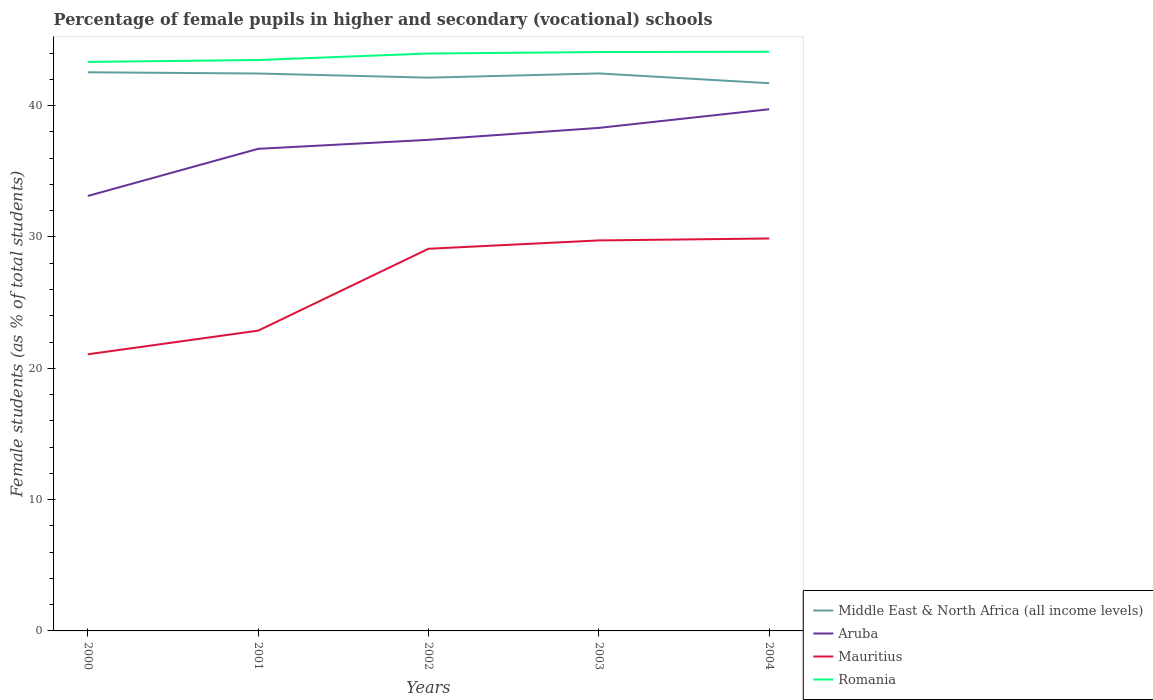Does the line corresponding to Aruba intersect with the line corresponding to Middle East & North Africa (all income levels)?
Your response must be concise. No. Across all years, what is the maximum percentage of female pupils in higher and secondary schools in Romania?
Make the answer very short. 43.33. What is the total percentage of female pupils in higher and secondary schools in Romania in the graph?
Provide a short and direct response. -0.14. What is the difference between the highest and the second highest percentage of female pupils in higher and secondary schools in Middle East & North Africa (all income levels)?
Provide a succinct answer. 0.83. Is the percentage of female pupils in higher and secondary schools in Romania strictly greater than the percentage of female pupils in higher and secondary schools in Aruba over the years?
Make the answer very short. No. How many years are there in the graph?
Offer a terse response. 5. What is the difference between two consecutive major ticks on the Y-axis?
Keep it short and to the point. 10. Does the graph contain grids?
Provide a succinct answer. No. How many legend labels are there?
Provide a succinct answer. 4. How are the legend labels stacked?
Ensure brevity in your answer.  Vertical. What is the title of the graph?
Give a very brief answer. Percentage of female pupils in higher and secondary (vocational) schools. What is the label or title of the Y-axis?
Your answer should be very brief. Female students (as % of total students). What is the Female students (as % of total students) of Middle East & North Africa (all income levels) in 2000?
Your response must be concise. 42.54. What is the Female students (as % of total students) in Aruba in 2000?
Offer a very short reply. 33.12. What is the Female students (as % of total students) of Mauritius in 2000?
Keep it short and to the point. 21.06. What is the Female students (as % of total students) of Romania in 2000?
Provide a succinct answer. 43.33. What is the Female students (as % of total students) in Middle East & North Africa (all income levels) in 2001?
Give a very brief answer. 42.45. What is the Female students (as % of total students) of Aruba in 2001?
Provide a short and direct response. 36.71. What is the Female students (as % of total students) of Mauritius in 2001?
Provide a short and direct response. 22.86. What is the Female students (as % of total students) in Romania in 2001?
Make the answer very short. 43.47. What is the Female students (as % of total students) in Middle East & North Africa (all income levels) in 2002?
Your answer should be compact. 42.13. What is the Female students (as % of total students) of Aruba in 2002?
Keep it short and to the point. 37.4. What is the Female students (as % of total students) in Mauritius in 2002?
Give a very brief answer. 29.1. What is the Female students (as % of total students) in Romania in 2002?
Keep it short and to the point. 43.97. What is the Female students (as % of total students) of Middle East & North Africa (all income levels) in 2003?
Provide a succinct answer. 42.45. What is the Female students (as % of total students) in Aruba in 2003?
Your answer should be compact. 38.3. What is the Female students (as % of total students) in Mauritius in 2003?
Ensure brevity in your answer.  29.74. What is the Female students (as % of total students) of Romania in 2003?
Provide a succinct answer. 44.08. What is the Female students (as % of total students) of Middle East & North Africa (all income levels) in 2004?
Provide a short and direct response. 41.71. What is the Female students (as % of total students) of Aruba in 2004?
Offer a very short reply. 39.72. What is the Female students (as % of total students) of Mauritius in 2004?
Keep it short and to the point. 29.88. What is the Female students (as % of total students) in Romania in 2004?
Provide a short and direct response. 44.11. Across all years, what is the maximum Female students (as % of total students) in Middle East & North Africa (all income levels)?
Offer a very short reply. 42.54. Across all years, what is the maximum Female students (as % of total students) in Aruba?
Give a very brief answer. 39.72. Across all years, what is the maximum Female students (as % of total students) in Mauritius?
Provide a succinct answer. 29.88. Across all years, what is the maximum Female students (as % of total students) of Romania?
Make the answer very short. 44.11. Across all years, what is the minimum Female students (as % of total students) in Middle East & North Africa (all income levels)?
Provide a short and direct response. 41.71. Across all years, what is the minimum Female students (as % of total students) in Aruba?
Give a very brief answer. 33.12. Across all years, what is the minimum Female students (as % of total students) of Mauritius?
Offer a very short reply. 21.06. Across all years, what is the minimum Female students (as % of total students) of Romania?
Your answer should be very brief. 43.33. What is the total Female students (as % of total students) of Middle East & North Africa (all income levels) in the graph?
Your answer should be compact. 211.27. What is the total Female students (as % of total students) of Aruba in the graph?
Keep it short and to the point. 185.26. What is the total Female students (as % of total students) of Mauritius in the graph?
Ensure brevity in your answer.  132.65. What is the total Female students (as % of total students) in Romania in the graph?
Your answer should be compact. 218.96. What is the difference between the Female students (as % of total students) of Middle East & North Africa (all income levels) in 2000 and that in 2001?
Your response must be concise. 0.09. What is the difference between the Female students (as % of total students) of Aruba in 2000 and that in 2001?
Provide a short and direct response. -3.59. What is the difference between the Female students (as % of total students) in Mauritius in 2000 and that in 2001?
Keep it short and to the point. -1.8. What is the difference between the Female students (as % of total students) in Romania in 2000 and that in 2001?
Offer a very short reply. -0.14. What is the difference between the Female students (as % of total students) of Middle East & North Africa (all income levels) in 2000 and that in 2002?
Provide a succinct answer. 0.41. What is the difference between the Female students (as % of total students) of Aruba in 2000 and that in 2002?
Ensure brevity in your answer.  -4.28. What is the difference between the Female students (as % of total students) in Mauritius in 2000 and that in 2002?
Make the answer very short. -8.04. What is the difference between the Female students (as % of total students) in Romania in 2000 and that in 2002?
Ensure brevity in your answer.  -0.64. What is the difference between the Female students (as % of total students) in Middle East & North Africa (all income levels) in 2000 and that in 2003?
Make the answer very short. 0.09. What is the difference between the Female students (as % of total students) in Aruba in 2000 and that in 2003?
Your answer should be compact. -5.18. What is the difference between the Female students (as % of total students) in Mauritius in 2000 and that in 2003?
Make the answer very short. -8.67. What is the difference between the Female students (as % of total students) of Romania in 2000 and that in 2003?
Your response must be concise. -0.75. What is the difference between the Female students (as % of total students) in Middle East & North Africa (all income levels) in 2000 and that in 2004?
Keep it short and to the point. 0.83. What is the difference between the Female students (as % of total students) in Aruba in 2000 and that in 2004?
Your answer should be very brief. -6.6. What is the difference between the Female students (as % of total students) in Mauritius in 2000 and that in 2004?
Make the answer very short. -8.82. What is the difference between the Female students (as % of total students) of Romania in 2000 and that in 2004?
Provide a short and direct response. -0.78. What is the difference between the Female students (as % of total students) in Middle East & North Africa (all income levels) in 2001 and that in 2002?
Provide a short and direct response. 0.32. What is the difference between the Female students (as % of total students) of Aruba in 2001 and that in 2002?
Offer a terse response. -0.69. What is the difference between the Female students (as % of total students) in Mauritius in 2001 and that in 2002?
Your response must be concise. -6.24. What is the difference between the Female students (as % of total students) in Romania in 2001 and that in 2002?
Your answer should be compact. -0.5. What is the difference between the Female students (as % of total students) of Middle East & North Africa (all income levels) in 2001 and that in 2003?
Make the answer very short. -0.01. What is the difference between the Female students (as % of total students) in Aruba in 2001 and that in 2003?
Give a very brief answer. -1.59. What is the difference between the Female students (as % of total students) in Mauritius in 2001 and that in 2003?
Provide a succinct answer. -6.87. What is the difference between the Female students (as % of total students) of Romania in 2001 and that in 2003?
Make the answer very short. -0.61. What is the difference between the Female students (as % of total students) in Middle East & North Africa (all income levels) in 2001 and that in 2004?
Provide a short and direct response. 0.74. What is the difference between the Female students (as % of total students) in Aruba in 2001 and that in 2004?
Keep it short and to the point. -3.01. What is the difference between the Female students (as % of total students) in Mauritius in 2001 and that in 2004?
Make the answer very short. -7.02. What is the difference between the Female students (as % of total students) of Romania in 2001 and that in 2004?
Your answer should be compact. -0.63. What is the difference between the Female students (as % of total students) of Middle East & North Africa (all income levels) in 2002 and that in 2003?
Offer a very short reply. -0.32. What is the difference between the Female students (as % of total students) of Aruba in 2002 and that in 2003?
Your answer should be very brief. -0.91. What is the difference between the Female students (as % of total students) in Mauritius in 2002 and that in 2003?
Your response must be concise. -0.64. What is the difference between the Female students (as % of total students) in Romania in 2002 and that in 2003?
Provide a succinct answer. -0.11. What is the difference between the Female students (as % of total students) of Middle East & North Africa (all income levels) in 2002 and that in 2004?
Offer a terse response. 0.42. What is the difference between the Female students (as % of total students) of Aruba in 2002 and that in 2004?
Keep it short and to the point. -2.33. What is the difference between the Female students (as % of total students) in Mauritius in 2002 and that in 2004?
Your answer should be compact. -0.78. What is the difference between the Female students (as % of total students) in Romania in 2002 and that in 2004?
Give a very brief answer. -0.14. What is the difference between the Female students (as % of total students) of Middle East & North Africa (all income levels) in 2003 and that in 2004?
Your answer should be compact. 0.74. What is the difference between the Female students (as % of total students) of Aruba in 2003 and that in 2004?
Offer a very short reply. -1.42. What is the difference between the Female students (as % of total students) in Mauritius in 2003 and that in 2004?
Offer a very short reply. -0.15. What is the difference between the Female students (as % of total students) of Romania in 2003 and that in 2004?
Your answer should be very brief. -0.03. What is the difference between the Female students (as % of total students) of Middle East & North Africa (all income levels) in 2000 and the Female students (as % of total students) of Aruba in 2001?
Your answer should be very brief. 5.83. What is the difference between the Female students (as % of total students) of Middle East & North Africa (all income levels) in 2000 and the Female students (as % of total students) of Mauritius in 2001?
Provide a short and direct response. 19.67. What is the difference between the Female students (as % of total students) of Middle East & North Africa (all income levels) in 2000 and the Female students (as % of total students) of Romania in 2001?
Your answer should be compact. -0.93. What is the difference between the Female students (as % of total students) of Aruba in 2000 and the Female students (as % of total students) of Mauritius in 2001?
Give a very brief answer. 10.26. What is the difference between the Female students (as % of total students) of Aruba in 2000 and the Female students (as % of total students) of Romania in 2001?
Provide a short and direct response. -10.35. What is the difference between the Female students (as % of total students) in Mauritius in 2000 and the Female students (as % of total students) in Romania in 2001?
Offer a very short reply. -22.41. What is the difference between the Female students (as % of total students) in Middle East & North Africa (all income levels) in 2000 and the Female students (as % of total students) in Aruba in 2002?
Offer a terse response. 5.14. What is the difference between the Female students (as % of total students) of Middle East & North Africa (all income levels) in 2000 and the Female students (as % of total students) of Mauritius in 2002?
Keep it short and to the point. 13.44. What is the difference between the Female students (as % of total students) of Middle East & North Africa (all income levels) in 2000 and the Female students (as % of total students) of Romania in 2002?
Provide a short and direct response. -1.43. What is the difference between the Female students (as % of total students) in Aruba in 2000 and the Female students (as % of total students) in Mauritius in 2002?
Ensure brevity in your answer.  4.02. What is the difference between the Female students (as % of total students) of Aruba in 2000 and the Female students (as % of total students) of Romania in 2002?
Your response must be concise. -10.85. What is the difference between the Female students (as % of total students) of Mauritius in 2000 and the Female students (as % of total students) of Romania in 2002?
Give a very brief answer. -22.91. What is the difference between the Female students (as % of total students) in Middle East & North Africa (all income levels) in 2000 and the Female students (as % of total students) in Aruba in 2003?
Your answer should be very brief. 4.23. What is the difference between the Female students (as % of total students) of Middle East & North Africa (all income levels) in 2000 and the Female students (as % of total students) of Mauritius in 2003?
Your answer should be compact. 12.8. What is the difference between the Female students (as % of total students) in Middle East & North Africa (all income levels) in 2000 and the Female students (as % of total students) in Romania in 2003?
Offer a very short reply. -1.54. What is the difference between the Female students (as % of total students) of Aruba in 2000 and the Female students (as % of total students) of Mauritius in 2003?
Ensure brevity in your answer.  3.39. What is the difference between the Female students (as % of total students) of Aruba in 2000 and the Female students (as % of total students) of Romania in 2003?
Provide a succinct answer. -10.96. What is the difference between the Female students (as % of total students) of Mauritius in 2000 and the Female students (as % of total students) of Romania in 2003?
Make the answer very short. -23.02. What is the difference between the Female students (as % of total students) in Middle East & North Africa (all income levels) in 2000 and the Female students (as % of total students) in Aruba in 2004?
Keep it short and to the point. 2.81. What is the difference between the Female students (as % of total students) in Middle East & North Africa (all income levels) in 2000 and the Female students (as % of total students) in Mauritius in 2004?
Your response must be concise. 12.66. What is the difference between the Female students (as % of total students) of Middle East & North Africa (all income levels) in 2000 and the Female students (as % of total students) of Romania in 2004?
Your response must be concise. -1.57. What is the difference between the Female students (as % of total students) of Aruba in 2000 and the Female students (as % of total students) of Mauritius in 2004?
Your response must be concise. 3.24. What is the difference between the Female students (as % of total students) of Aruba in 2000 and the Female students (as % of total students) of Romania in 2004?
Make the answer very short. -10.99. What is the difference between the Female students (as % of total students) of Mauritius in 2000 and the Female students (as % of total students) of Romania in 2004?
Give a very brief answer. -23.04. What is the difference between the Female students (as % of total students) in Middle East & North Africa (all income levels) in 2001 and the Female students (as % of total students) in Aruba in 2002?
Make the answer very short. 5.05. What is the difference between the Female students (as % of total students) of Middle East & North Africa (all income levels) in 2001 and the Female students (as % of total students) of Mauritius in 2002?
Your answer should be compact. 13.35. What is the difference between the Female students (as % of total students) of Middle East & North Africa (all income levels) in 2001 and the Female students (as % of total students) of Romania in 2002?
Provide a short and direct response. -1.52. What is the difference between the Female students (as % of total students) in Aruba in 2001 and the Female students (as % of total students) in Mauritius in 2002?
Your answer should be very brief. 7.61. What is the difference between the Female students (as % of total students) of Aruba in 2001 and the Female students (as % of total students) of Romania in 2002?
Your answer should be very brief. -7.26. What is the difference between the Female students (as % of total students) in Mauritius in 2001 and the Female students (as % of total students) in Romania in 2002?
Keep it short and to the point. -21.1. What is the difference between the Female students (as % of total students) in Middle East & North Africa (all income levels) in 2001 and the Female students (as % of total students) in Aruba in 2003?
Offer a terse response. 4.14. What is the difference between the Female students (as % of total students) in Middle East & North Africa (all income levels) in 2001 and the Female students (as % of total students) in Mauritius in 2003?
Make the answer very short. 12.71. What is the difference between the Female students (as % of total students) in Middle East & North Africa (all income levels) in 2001 and the Female students (as % of total students) in Romania in 2003?
Ensure brevity in your answer.  -1.63. What is the difference between the Female students (as % of total students) in Aruba in 2001 and the Female students (as % of total students) in Mauritius in 2003?
Provide a succinct answer. 6.97. What is the difference between the Female students (as % of total students) in Aruba in 2001 and the Female students (as % of total students) in Romania in 2003?
Give a very brief answer. -7.37. What is the difference between the Female students (as % of total students) in Mauritius in 2001 and the Female students (as % of total students) in Romania in 2003?
Your response must be concise. -21.21. What is the difference between the Female students (as % of total students) in Middle East & North Africa (all income levels) in 2001 and the Female students (as % of total students) in Aruba in 2004?
Make the answer very short. 2.72. What is the difference between the Female students (as % of total students) of Middle East & North Africa (all income levels) in 2001 and the Female students (as % of total students) of Mauritius in 2004?
Your response must be concise. 12.56. What is the difference between the Female students (as % of total students) in Middle East & North Africa (all income levels) in 2001 and the Female students (as % of total students) in Romania in 2004?
Your answer should be compact. -1.66. What is the difference between the Female students (as % of total students) of Aruba in 2001 and the Female students (as % of total students) of Mauritius in 2004?
Ensure brevity in your answer.  6.83. What is the difference between the Female students (as % of total students) of Aruba in 2001 and the Female students (as % of total students) of Romania in 2004?
Keep it short and to the point. -7.4. What is the difference between the Female students (as % of total students) in Mauritius in 2001 and the Female students (as % of total students) in Romania in 2004?
Your answer should be compact. -21.24. What is the difference between the Female students (as % of total students) of Middle East & North Africa (all income levels) in 2002 and the Female students (as % of total students) of Aruba in 2003?
Offer a terse response. 3.83. What is the difference between the Female students (as % of total students) in Middle East & North Africa (all income levels) in 2002 and the Female students (as % of total students) in Mauritius in 2003?
Offer a very short reply. 12.39. What is the difference between the Female students (as % of total students) in Middle East & North Africa (all income levels) in 2002 and the Female students (as % of total students) in Romania in 2003?
Provide a succinct answer. -1.95. What is the difference between the Female students (as % of total students) of Aruba in 2002 and the Female students (as % of total students) of Mauritius in 2003?
Offer a very short reply. 7.66. What is the difference between the Female students (as % of total students) of Aruba in 2002 and the Female students (as % of total students) of Romania in 2003?
Your answer should be compact. -6.68. What is the difference between the Female students (as % of total students) of Mauritius in 2002 and the Female students (as % of total students) of Romania in 2003?
Provide a short and direct response. -14.98. What is the difference between the Female students (as % of total students) in Middle East & North Africa (all income levels) in 2002 and the Female students (as % of total students) in Aruba in 2004?
Keep it short and to the point. 2.4. What is the difference between the Female students (as % of total students) of Middle East & North Africa (all income levels) in 2002 and the Female students (as % of total students) of Mauritius in 2004?
Ensure brevity in your answer.  12.25. What is the difference between the Female students (as % of total students) of Middle East & North Africa (all income levels) in 2002 and the Female students (as % of total students) of Romania in 2004?
Your response must be concise. -1.98. What is the difference between the Female students (as % of total students) in Aruba in 2002 and the Female students (as % of total students) in Mauritius in 2004?
Give a very brief answer. 7.51. What is the difference between the Female students (as % of total students) of Aruba in 2002 and the Female students (as % of total students) of Romania in 2004?
Ensure brevity in your answer.  -6.71. What is the difference between the Female students (as % of total students) in Mauritius in 2002 and the Female students (as % of total students) in Romania in 2004?
Provide a succinct answer. -15.01. What is the difference between the Female students (as % of total students) of Middle East & North Africa (all income levels) in 2003 and the Female students (as % of total students) of Aruba in 2004?
Keep it short and to the point. 2.73. What is the difference between the Female students (as % of total students) in Middle East & North Africa (all income levels) in 2003 and the Female students (as % of total students) in Mauritius in 2004?
Ensure brevity in your answer.  12.57. What is the difference between the Female students (as % of total students) in Middle East & North Africa (all income levels) in 2003 and the Female students (as % of total students) in Romania in 2004?
Provide a short and direct response. -1.66. What is the difference between the Female students (as % of total students) of Aruba in 2003 and the Female students (as % of total students) of Mauritius in 2004?
Your answer should be compact. 8.42. What is the difference between the Female students (as % of total students) of Aruba in 2003 and the Female students (as % of total students) of Romania in 2004?
Your answer should be compact. -5.8. What is the difference between the Female students (as % of total students) in Mauritius in 2003 and the Female students (as % of total students) in Romania in 2004?
Your answer should be compact. -14.37. What is the average Female students (as % of total students) of Middle East & North Africa (all income levels) per year?
Offer a very short reply. 42.25. What is the average Female students (as % of total students) of Aruba per year?
Give a very brief answer. 37.05. What is the average Female students (as % of total students) of Mauritius per year?
Your answer should be very brief. 26.53. What is the average Female students (as % of total students) of Romania per year?
Offer a terse response. 43.79. In the year 2000, what is the difference between the Female students (as % of total students) of Middle East & North Africa (all income levels) and Female students (as % of total students) of Aruba?
Make the answer very short. 9.42. In the year 2000, what is the difference between the Female students (as % of total students) in Middle East & North Africa (all income levels) and Female students (as % of total students) in Mauritius?
Provide a succinct answer. 21.48. In the year 2000, what is the difference between the Female students (as % of total students) in Middle East & North Africa (all income levels) and Female students (as % of total students) in Romania?
Offer a terse response. -0.79. In the year 2000, what is the difference between the Female students (as % of total students) of Aruba and Female students (as % of total students) of Mauritius?
Offer a terse response. 12.06. In the year 2000, what is the difference between the Female students (as % of total students) in Aruba and Female students (as % of total students) in Romania?
Give a very brief answer. -10.21. In the year 2000, what is the difference between the Female students (as % of total students) in Mauritius and Female students (as % of total students) in Romania?
Your answer should be compact. -22.27. In the year 2001, what is the difference between the Female students (as % of total students) in Middle East & North Africa (all income levels) and Female students (as % of total students) in Aruba?
Offer a very short reply. 5.74. In the year 2001, what is the difference between the Female students (as % of total students) of Middle East & North Africa (all income levels) and Female students (as % of total students) of Mauritius?
Offer a terse response. 19.58. In the year 2001, what is the difference between the Female students (as % of total students) in Middle East & North Africa (all income levels) and Female students (as % of total students) in Romania?
Offer a terse response. -1.03. In the year 2001, what is the difference between the Female students (as % of total students) of Aruba and Female students (as % of total students) of Mauritius?
Offer a terse response. 13.85. In the year 2001, what is the difference between the Female students (as % of total students) in Aruba and Female students (as % of total students) in Romania?
Give a very brief answer. -6.76. In the year 2001, what is the difference between the Female students (as % of total students) in Mauritius and Female students (as % of total students) in Romania?
Provide a short and direct response. -20.61. In the year 2002, what is the difference between the Female students (as % of total students) in Middle East & North Africa (all income levels) and Female students (as % of total students) in Aruba?
Provide a succinct answer. 4.73. In the year 2002, what is the difference between the Female students (as % of total students) of Middle East & North Africa (all income levels) and Female students (as % of total students) of Mauritius?
Your response must be concise. 13.03. In the year 2002, what is the difference between the Female students (as % of total students) in Middle East & North Africa (all income levels) and Female students (as % of total students) in Romania?
Keep it short and to the point. -1.84. In the year 2002, what is the difference between the Female students (as % of total students) of Aruba and Female students (as % of total students) of Mauritius?
Ensure brevity in your answer.  8.3. In the year 2002, what is the difference between the Female students (as % of total students) in Aruba and Female students (as % of total students) in Romania?
Your answer should be compact. -6.57. In the year 2002, what is the difference between the Female students (as % of total students) in Mauritius and Female students (as % of total students) in Romania?
Offer a very short reply. -14.87. In the year 2003, what is the difference between the Female students (as % of total students) of Middle East & North Africa (all income levels) and Female students (as % of total students) of Aruba?
Provide a short and direct response. 4.15. In the year 2003, what is the difference between the Female students (as % of total students) in Middle East & North Africa (all income levels) and Female students (as % of total students) in Mauritius?
Your answer should be very brief. 12.72. In the year 2003, what is the difference between the Female students (as % of total students) of Middle East & North Africa (all income levels) and Female students (as % of total students) of Romania?
Give a very brief answer. -1.63. In the year 2003, what is the difference between the Female students (as % of total students) in Aruba and Female students (as % of total students) in Mauritius?
Provide a short and direct response. 8.57. In the year 2003, what is the difference between the Female students (as % of total students) of Aruba and Female students (as % of total students) of Romania?
Offer a terse response. -5.77. In the year 2003, what is the difference between the Female students (as % of total students) in Mauritius and Female students (as % of total students) in Romania?
Offer a very short reply. -14.34. In the year 2004, what is the difference between the Female students (as % of total students) in Middle East & North Africa (all income levels) and Female students (as % of total students) in Aruba?
Give a very brief answer. 1.98. In the year 2004, what is the difference between the Female students (as % of total students) of Middle East & North Africa (all income levels) and Female students (as % of total students) of Mauritius?
Your response must be concise. 11.82. In the year 2004, what is the difference between the Female students (as % of total students) of Middle East & North Africa (all income levels) and Female students (as % of total students) of Romania?
Offer a terse response. -2.4. In the year 2004, what is the difference between the Female students (as % of total students) in Aruba and Female students (as % of total students) in Mauritius?
Provide a short and direct response. 9.84. In the year 2004, what is the difference between the Female students (as % of total students) in Aruba and Female students (as % of total students) in Romania?
Your response must be concise. -4.38. In the year 2004, what is the difference between the Female students (as % of total students) in Mauritius and Female students (as % of total students) in Romania?
Offer a terse response. -14.22. What is the ratio of the Female students (as % of total students) of Aruba in 2000 to that in 2001?
Offer a terse response. 0.9. What is the ratio of the Female students (as % of total students) in Mauritius in 2000 to that in 2001?
Your answer should be very brief. 0.92. What is the ratio of the Female students (as % of total students) in Romania in 2000 to that in 2001?
Provide a succinct answer. 1. What is the ratio of the Female students (as % of total students) in Middle East & North Africa (all income levels) in 2000 to that in 2002?
Give a very brief answer. 1.01. What is the ratio of the Female students (as % of total students) in Aruba in 2000 to that in 2002?
Keep it short and to the point. 0.89. What is the ratio of the Female students (as % of total students) of Mauritius in 2000 to that in 2002?
Provide a short and direct response. 0.72. What is the ratio of the Female students (as % of total students) of Romania in 2000 to that in 2002?
Your response must be concise. 0.99. What is the ratio of the Female students (as % of total students) of Middle East & North Africa (all income levels) in 2000 to that in 2003?
Provide a short and direct response. 1. What is the ratio of the Female students (as % of total students) of Aruba in 2000 to that in 2003?
Give a very brief answer. 0.86. What is the ratio of the Female students (as % of total students) of Mauritius in 2000 to that in 2003?
Offer a very short reply. 0.71. What is the ratio of the Female students (as % of total students) in Middle East & North Africa (all income levels) in 2000 to that in 2004?
Your response must be concise. 1.02. What is the ratio of the Female students (as % of total students) of Aruba in 2000 to that in 2004?
Offer a very short reply. 0.83. What is the ratio of the Female students (as % of total students) in Mauritius in 2000 to that in 2004?
Give a very brief answer. 0.7. What is the ratio of the Female students (as % of total students) in Romania in 2000 to that in 2004?
Offer a very short reply. 0.98. What is the ratio of the Female students (as % of total students) in Middle East & North Africa (all income levels) in 2001 to that in 2002?
Keep it short and to the point. 1.01. What is the ratio of the Female students (as % of total students) of Aruba in 2001 to that in 2002?
Ensure brevity in your answer.  0.98. What is the ratio of the Female students (as % of total students) of Mauritius in 2001 to that in 2002?
Provide a succinct answer. 0.79. What is the ratio of the Female students (as % of total students) in Romania in 2001 to that in 2002?
Give a very brief answer. 0.99. What is the ratio of the Female students (as % of total students) of Aruba in 2001 to that in 2003?
Offer a terse response. 0.96. What is the ratio of the Female students (as % of total students) in Mauritius in 2001 to that in 2003?
Provide a succinct answer. 0.77. What is the ratio of the Female students (as % of total students) in Romania in 2001 to that in 2003?
Make the answer very short. 0.99. What is the ratio of the Female students (as % of total students) of Middle East & North Africa (all income levels) in 2001 to that in 2004?
Your answer should be very brief. 1.02. What is the ratio of the Female students (as % of total students) of Aruba in 2001 to that in 2004?
Make the answer very short. 0.92. What is the ratio of the Female students (as % of total students) in Mauritius in 2001 to that in 2004?
Make the answer very short. 0.77. What is the ratio of the Female students (as % of total students) in Romania in 2001 to that in 2004?
Keep it short and to the point. 0.99. What is the ratio of the Female students (as % of total students) of Aruba in 2002 to that in 2003?
Offer a terse response. 0.98. What is the ratio of the Female students (as % of total students) of Mauritius in 2002 to that in 2003?
Provide a succinct answer. 0.98. What is the ratio of the Female students (as % of total students) of Middle East & North Africa (all income levels) in 2002 to that in 2004?
Give a very brief answer. 1.01. What is the ratio of the Female students (as % of total students) in Aruba in 2002 to that in 2004?
Offer a very short reply. 0.94. What is the ratio of the Female students (as % of total students) of Mauritius in 2002 to that in 2004?
Ensure brevity in your answer.  0.97. What is the ratio of the Female students (as % of total students) of Romania in 2002 to that in 2004?
Make the answer very short. 1. What is the ratio of the Female students (as % of total students) of Middle East & North Africa (all income levels) in 2003 to that in 2004?
Your response must be concise. 1.02. What is the ratio of the Female students (as % of total students) of Aruba in 2003 to that in 2004?
Your answer should be compact. 0.96. What is the difference between the highest and the second highest Female students (as % of total students) of Middle East & North Africa (all income levels)?
Offer a terse response. 0.09. What is the difference between the highest and the second highest Female students (as % of total students) in Aruba?
Ensure brevity in your answer.  1.42. What is the difference between the highest and the second highest Female students (as % of total students) of Mauritius?
Provide a succinct answer. 0.15. What is the difference between the highest and the second highest Female students (as % of total students) of Romania?
Provide a succinct answer. 0.03. What is the difference between the highest and the lowest Female students (as % of total students) of Middle East & North Africa (all income levels)?
Your answer should be very brief. 0.83. What is the difference between the highest and the lowest Female students (as % of total students) of Aruba?
Ensure brevity in your answer.  6.6. What is the difference between the highest and the lowest Female students (as % of total students) of Mauritius?
Offer a terse response. 8.82. What is the difference between the highest and the lowest Female students (as % of total students) of Romania?
Offer a very short reply. 0.78. 